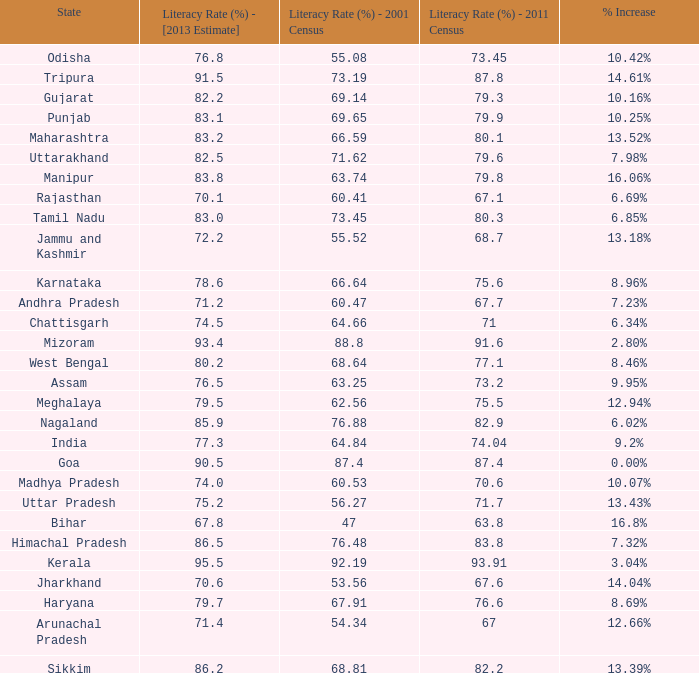What was the literacy rate published in the 2001 census for the state that saw a 12.66% increase? 54.34. Parse the table in full. {'header': ['State', 'Literacy Rate (%) - [2013 Estimate]', 'Literacy Rate (%) - 2001 Census', 'Literacy Rate (%) - 2011 Census', '% Increase'], 'rows': [['Odisha', '76.8', '55.08', '73.45', '10.42%'], ['Tripura', '91.5', '73.19', '87.8', '14.61%'], ['Gujarat', '82.2', '69.14', '79.3', '10.16%'], ['Punjab', '83.1', '69.65', '79.9', '10.25%'], ['Maharashtra', '83.2', '66.59', '80.1', '13.52%'], ['Uttarakhand', '82.5', '71.62', '79.6', '7.98%'], ['Manipur', '83.8', '63.74', '79.8', '16.06%'], ['Rajasthan', '70.1', '60.41', '67.1', '6.69%'], ['Tamil Nadu', '83.0', '73.45', '80.3', '6.85%'], ['Jammu and Kashmir', '72.2', '55.52', '68.7', '13.18%'], ['Karnataka', '78.6', '66.64', '75.6', '8.96%'], ['Andhra Pradesh', '71.2', '60.47', '67.7', '7.23%'], ['Chattisgarh', '74.5', '64.66', '71', '6.34%'], ['Mizoram', '93.4', '88.8', '91.6', '2.80%'], ['West Bengal', '80.2', '68.64', '77.1', '8.46%'], ['Assam', '76.5', '63.25', '73.2', '9.95%'], ['Meghalaya', '79.5', '62.56', '75.5', '12.94%'], ['Nagaland', '85.9', '76.88', '82.9', '6.02%'], ['India', '77.3', '64.84', '74.04', '9.2%'], ['Goa', '90.5', '87.4', '87.4', '0.00%'], ['Madhya Pradesh', '74.0', '60.53', '70.6', '10.07%'], ['Uttar Pradesh', '75.2', '56.27', '71.7', '13.43%'], ['Bihar', '67.8', '47', '63.8', '16.8%'], ['Himachal Pradesh', '86.5', '76.48', '83.8', '7.32%'], ['Kerala', '95.5', '92.19', '93.91', '3.04%'], ['Jharkhand', '70.6', '53.56', '67.6', '14.04%'], ['Haryana', '79.7', '67.91', '76.6', '8.69%'], ['Arunachal Pradesh', '71.4', '54.34', '67', '12.66%'], ['Sikkim', '86.2', '68.81', '82.2', '13.39%']]} 